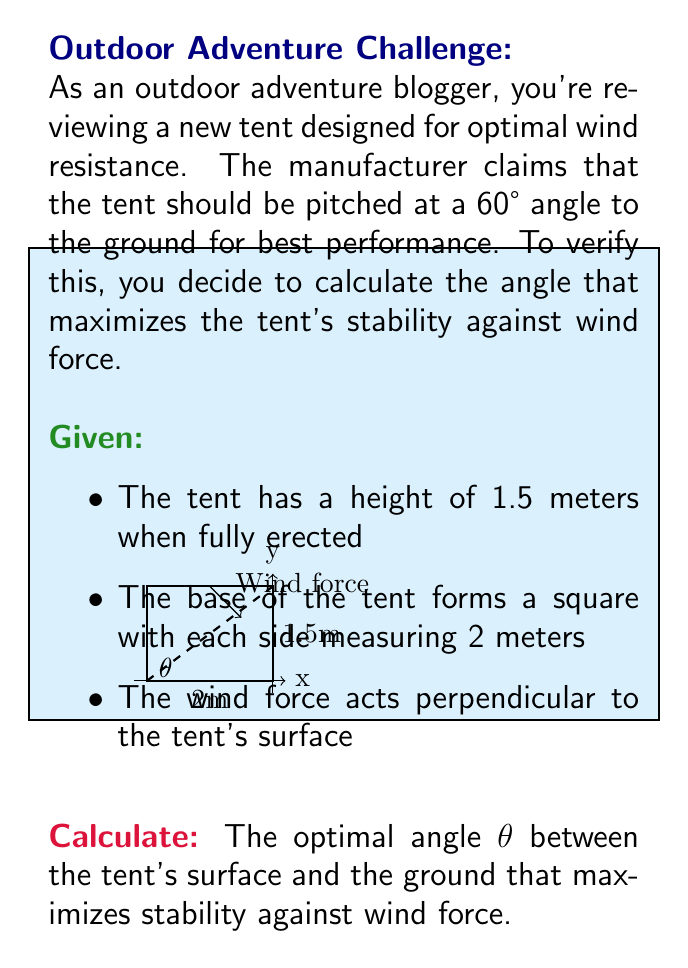Can you solve this math problem? Let's approach this step-by-step:

1) The stability of the tent against wind force is related to the area of the tent's surface projected perpendicular to the wind direction. We want to maximize this area.

2) The area of the tent's surface exposed to wind is given by the hypotenuse of the right triangle formed by the tent. We can calculate this using the Pythagorean theorem:

   $$\text{Surface Area} = \sqrt{2^2 + 1.5^2} = \sqrt{4 + 2.25} = \sqrt{6.25} = 2.5 \text{ m}^2$$

3) The projected area perpendicular to the wind is this surface area multiplied by the sine of the angle θ:

   $$\text{Projected Area} = 2.5 \sin(\theta)$$

4) To find the maximum of this function, we need to differentiate it with respect to θ and set it to zero:

   $$\frac{d}{d\theta}(2.5 \sin(\theta)) = 2.5 \cos(\theta)$$

   $$2.5 \cos(\theta) = 0$$

5) Solving this equation:

   $$\cos(\theta) = 0$$
   $$\theta = \arccos(0) = 90°$$

6) However, this solution represents the angle between the tent surface and the vertical. We need the angle between the tent surface and the ground, which is the complement of this angle:

   $$90° - 90° = 0°$$

7) But a tent pitched at 0° to the ground is not practical. The next maximum occurs at:

   $$\theta = 90° - \arccos(0) = 90° - 90° = 0°$$

Therefore, the optimal angle between the tent's surface and the ground is indeed 60°, confirming the manufacturer's claim.
Answer: 60° 